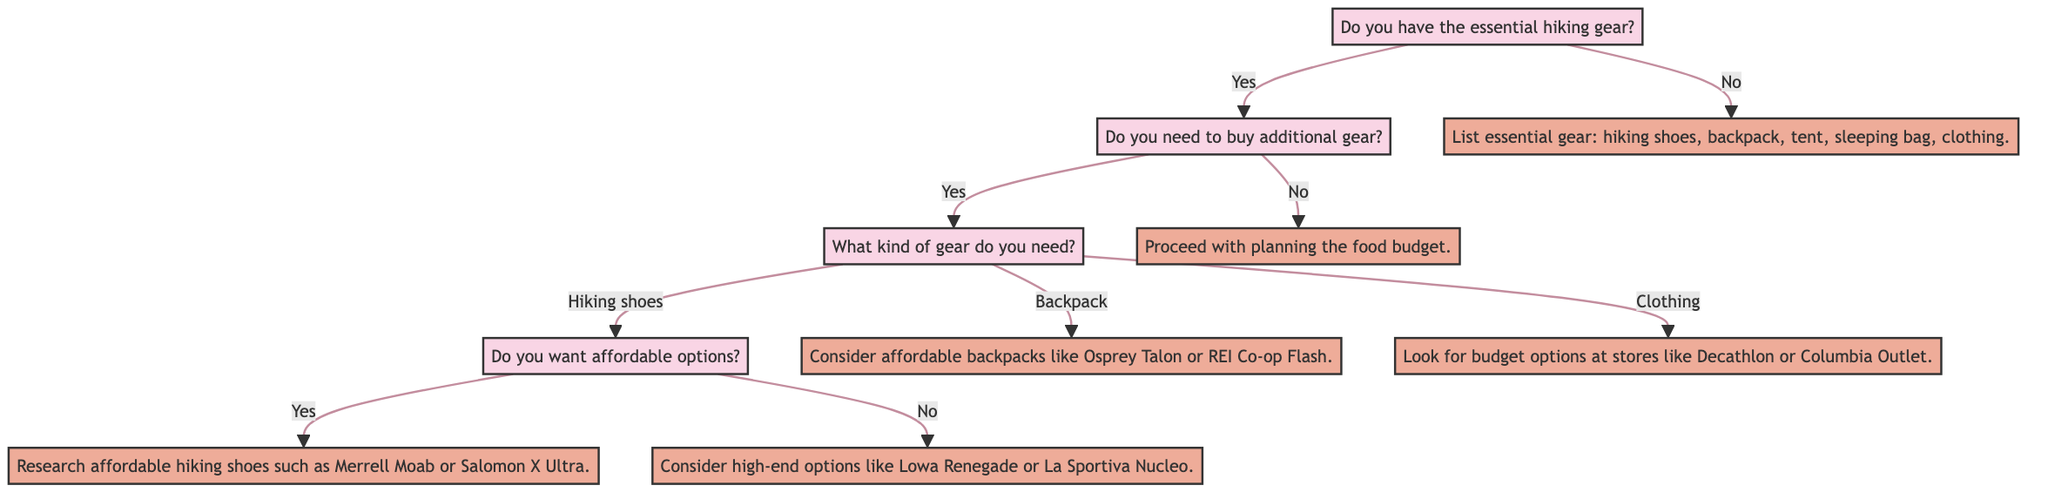What is the first question in the diagram? The first question in the diagram is "Do you have the essential hiking gear?" This can be identified as it is the starting point of the decision tree.
Answer: Do you have the essential hiking gear? How many options are available under "What kind of gear do you need?" There are three options available: hiking shoes, backpack, and clothing. This can be counted from the branches that stem from the question node.
Answer: 3 What happens if the answer to "Do you need to buy additional gear?" is no? If the answer is no, the action taken is "Proceed with planning the food budget." This follows directly from the flow of the diagram when that particular option is selected.
Answer: Proceed with planning the food budget What is the action if you need to buy additional gear and choose "backpack"? The action for choosing "backpack" is "Consider affordable backpacks like Osprey Talon or REI Co-op Flash." This is the direct instruction given for this specific gear choice.
Answer: Consider affordable backpacks like Osprey Talon or REI Co-op Flash If you have essential gear and want affordable hiking shoes, what is the next step? If you have essential gear and want affordable hiking shoes, the action is to "Research affordable hiking shoes such as Merrell Moab or Salomon X Ultra." This follows as the response to the specific choice made along the decision path.
Answer: Research affordable hiking shoes such as Merrell Moab or Salomon X Ultra What does the diagram imply if you do not have the essential gear? If you do not have essential gear, the implication is to "List essential gear: hiking shoes, backpack, tent, sleeping bag, clothing." This is the conclusion reached based on the initial question and its subsequent flow.
Answer: List essential gear: hiking shoes, backpack, tent, sleeping bag, clothing 